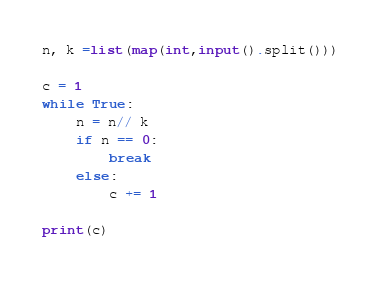Convert code to text. <code><loc_0><loc_0><loc_500><loc_500><_Python_>n, k =list(map(int,input().split()))

c = 1
while True:
    n = n// k
    if n == 0:
        break
    else:
        c += 1
        
print(c)
</code> 